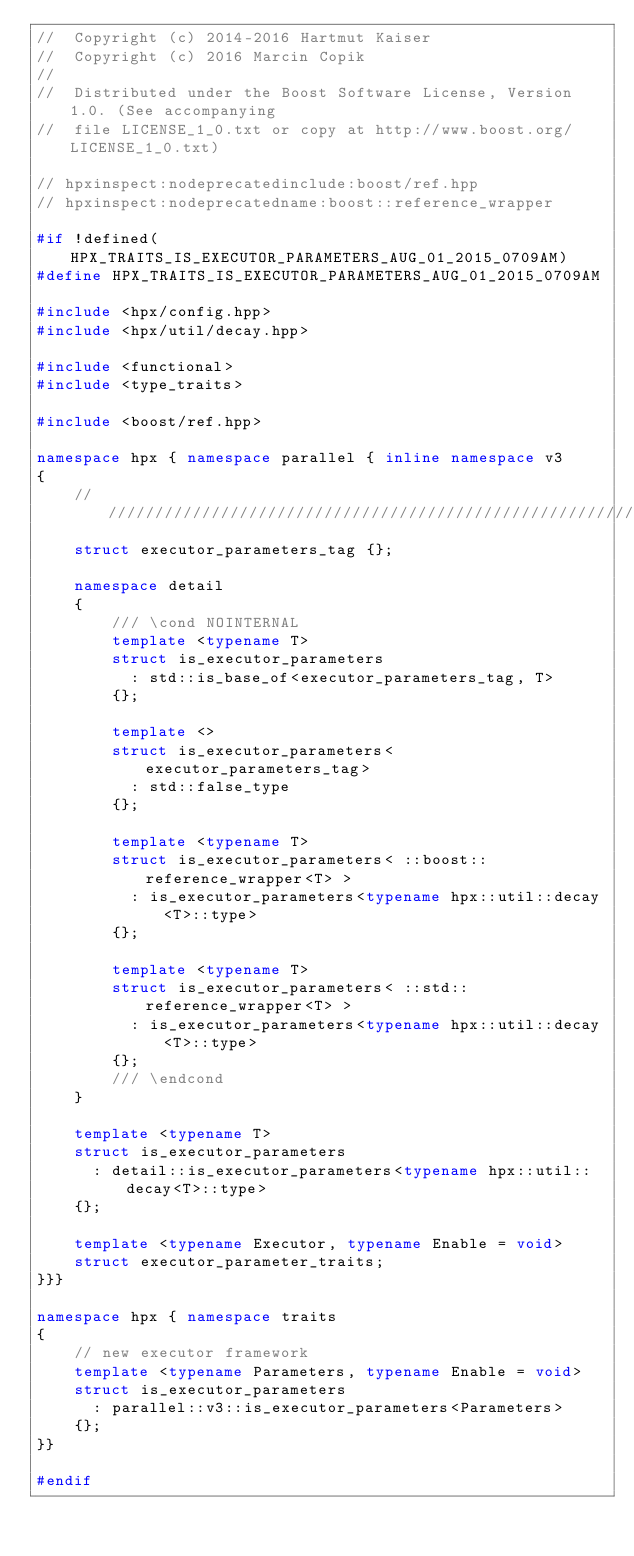<code> <loc_0><loc_0><loc_500><loc_500><_C++_>//  Copyright (c) 2014-2016 Hartmut Kaiser
//  Copyright (c) 2016 Marcin Copik
//
//  Distributed under the Boost Software License, Version 1.0. (See accompanying
//  file LICENSE_1_0.txt or copy at http://www.boost.org/LICENSE_1_0.txt)

// hpxinspect:nodeprecatedinclude:boost/ref.hpp
// hpxinspect:nodeprecatedname:boost::reference_wrapper

#if !defined(HPX_TRAITS_IS_EXECUTOR_PARAMETERS_AUG_01_2015_0709AM)
#define HPX_TRAITS_IS_EXECUTOR_PARAMETERS_AUG_01_2015_0709AM

#include <hpx/config.hpp>
#include <hpx/util/decay.hpp>

#include <functional>
#include <type_traits>

#include <boost/ref.hpp>

namespace hpx { namespace parallel { inline namespace v3
{
    ///////////////////////////////////////////////////////////////////////////
    struct executor_parameters_tag {};

    namespace detail
    {
        /// \cond NOINTERNAL
        template <typename T>
        struct is_executor_parameters
          : std::is_base_of<executor_parameters_tag, T>
        {};

        template <>
        struct is_executor_parameters<executor_parameters_tag>
          : std::false_type
        {};

        template <typename T>
        struct is_executor_parameters< ::boost::reference_wrapper<T> >
          : is_executor_parameters<typename hpx::util::decay<T>::type>
        {};

        template <typename T>
        struct is_executor_parameters< ::std::reference_wrapper<T> >
          : is_executor_parameters<typename hpx::util::decay<T>::type>
        {};
        /// \endcond
    }

    template <typename T>
    struct is_executor_parameters
      : detail::is_executor_parameters<typename hpx::util::decay<T>::type>
    {};

    template <typename Executor, typename Enable = void>
    struct executor_parameter_traits;
}}}

namespace hpx { namespace traits
{
    // new executor framework
    template <typename Parameters, typename Enable = void>
    struct is_executor_parameters
      : parallel::v3::is_executor_parameters<Parameters>
    {};
}}

#endif

</code> 